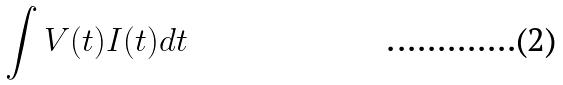<formula> <loc_0><loc_0><loc_500><loc_500>\int V ( t ) I ( t ) d t</formula> 